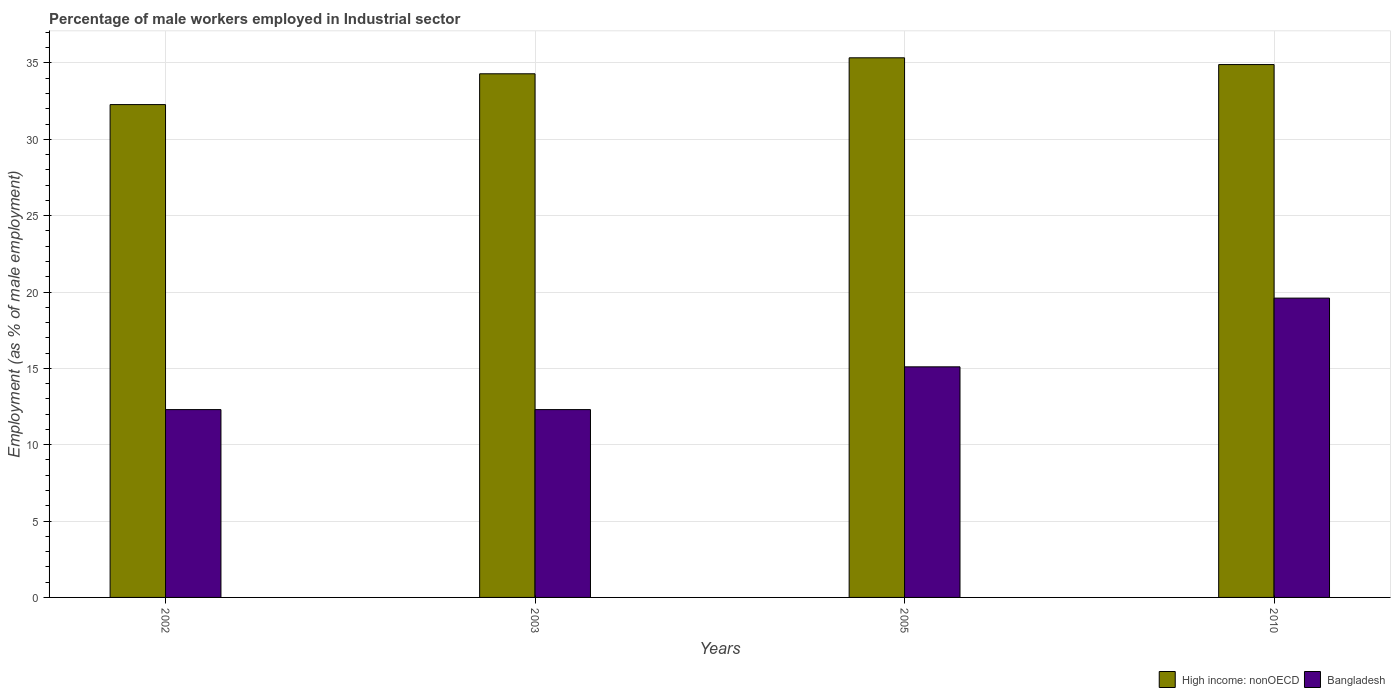How many different coloured bars are there?
Ensure brevity in your answer.  2. How many groups of bars are there?
Give a very brief answer. 4. Are the number of bars per tick equal to the number of legend labels?
Your answer should be compact. Yes. Are the number of bars on each tick of the X-axis equal?
Offer a terse response. Yes. How many bars are there on the 1st tick from the left?
Your answer should be compact. 2. What is the label of the 2nd group of bars from the left?
Provide a succinct answer. 2003. In how many cases, is the number of bars for a given year not equal to the number of legend labels?
Make the answer very short. 0. What is the percentage of male workers employed in Industrial sector in Bangladesh in 2002?
Make the answer very short. 12.3. Across all years, what is the maximum percentage of male workers employed in Industrial sector in High income: nonOECD?
Your response must be concise. 35.34. Across all years, what is the minimum percentage of male workers employed in Industrial sector in Bangladesh?
Make the answer very short. 12.3. What is the total percentage of male workers employed in Industrial sector in Bangladesh in the graph?
Provide a short and direct response. 59.3. What is the difference between the percentage of male workers employed in Industrial sector in High income: nonOECD in 2003 and that in 2010?
Ensure brevity in your answer.  -0.6. What is the difference between the percentage of male workers employed in Industrial sector in High income: nonOECD in 2010 and the percentage of male workers employed in Industrial sector in Bangladesh in 2005?
Your answer should be very brief. 19.79. What is the average percentage of male workers employed in Industrial sector in High income: nonOECD per year?
Your answer should be compact. 34.2. In the year 2010, what is the difference between the percentage of male workers employed in Industrial sector in Bangladesh and percentage of male workers employed in Industrial sector in High income: nonOECD?
Make the answer very short. -15.29. In how many years, is the percentage of male workers employed in Industrial sector in Bangladesh greater than 11 %?
Keep it short and to the point. 4. Is the percentage of male workers employed in Industrial sector in Bangladesh in 2005 less than that in 2010?
Keep it short and to the point. Yes. What is the difference between the highest and the second highest percentage of male workers employed in Industrial sector in High income: nonOECD?
Your answer should be very brief. 0.44. What is the difference between the highest and the lowest percentage of male workers employed in Industrial sector in Bangladesh?
Ensure brevity in your answer.  7.3. Is the sum of the percentage of male workers employed in Industrial sector in Bangladesh in 2003 and 2010 greater than the maximum percentage of male workers employed in Industrial sector in High income: nonOECD across all years?
Offer a terse response. No. What does the 2nd bar from the left in 2010 represents?
Ensure brevity in your answer.  Bangladesh. Does the graph contain grids?
Provide a short and direct response. Yes. Where does the legend appear in the graph?
Provide a succinct answer. Bottom right. How are the legend labels stacked?
Your answer should be very brief. Horizontal. What is the title of the graph?
Ensure brevity in your answer.  Percentage of male workers employed in Industrial sector. What is the label or title of the X-axis?
Your answer should be very brief. Years. What is the label or title of the Y-axis?
Offer a terse response. Employment (as % of male employment). What is the Employment (as % of male employment) of High income: nonOECD in 2002?
Make the answer very short. 32.27. What is the Employment (as % of male employment) of Bangladesh in 2002?
Your answer should be very brief. 12.3. What is the Employment (as % of male employment) in High income: nonOECD in 2003?
Your answer should be compact. 34.29. What is the Employment (as % of male employment) in Bangladesh in 2003?
Give a very brief answer. 12.3. What is the Employment (as % of male employment) in High income: nonOECD in 2005?
Give a very brief answer. 35.34. What is the Employment (as % of male employment) of Bangladesh in 2005?
Your response must be concise. 15.1. What is the Employment (as % of male employment) in High income: nonOECD in 2010?
Ensure brevity in your answer.  34.89. What is the Employment (as % of male employment) in Bangladesh in 2010?
Give a very brief answer. 19.6. Across all years, what is the maximum Employment (as % of male employment) of High income: nonOECD?
Keep it short and to the point. 35.34. Across all years, what is the maximum Employment (as % of male employment) in Bangladesh?
Provide a succinct answer. 19.6. Across all years, what is the minimum Employment (as % of male employment) of High income: nonOECD?
Offer a very short reply. 32.27. Across all years, what is the minimum Employment (as % of male employment) in Bangladesh?
Your response must be concise. 12.3. What is the total Employment (as % of male employment) of High income: nonOECD in the graph?
Your response must be concise. 136.79. What is the total Employment (as % of male employment) in Bangladesh in the graph?
Keep it short and to the point. 59.3. What is the difference between the Employment (as % of male employment) of High income: nonOECD in 2002 and that in 2003?
Give a very brief answer. -2.02. What is the difference between the Employment (as % of male employment) in High income: nonOECD in 2002 and that in 2005?
Make the answer very short. -3.06. What is the difference between the Employment (as % of male employment) of Bangladesh in 2002 and that in 2005?
Provide a short and direct response. -2.8. What is the difference between the Employment (as % of male employment) in High income: nonOECD in 2002 and that in 2010?
Your response must be concise. -2.62. What is the difference between the Employment (as % of male employment) of High income: nonOECD in 2003 and that in 2005?
Offer a very short reply. -1.05. What is the difference between the Employment (as % of male employment) of High income: nonOECD in 2003 and that in 2010?
Give a very brief answer. -0.6. What is the difference between the Employment (as % of male employment) of Bangladesh in 2003 and that in 2010?
Keep it short and to the point. -7.3. What is the difference between the Employment (as % of male employment) of High income: nonOECD in 2005 and that in 2010?
Your answer should be compact. 0.44. What is the difference between the Employment (as % of male employment) of Bangladesh in 2005 and that in 2010?
Keep it short and to the point. -4.5. What is the difference between the Employment (as % of male employment) in High income: nonOECD in 2002 and the Employment (as % of male employment) in Bangladesh in 2003?
Give a very brief answer. 19.97. What is the difference between the Employment (as % of male employment) in High income: nonOECD in 2002 and the Employment (as % of male employment) in Bangladesh in 2005?
Your answer should be very brief. 17.17. What is the difference between the Employment (as % of male employment) in High income: nonOECD in 2002 and the Employment (as % of male employment) in Bangladesh in 2010?
Offer a very short reply. 12.67. What is the difference between the Employment (as % of male employment) of High income: nonOECD in 2003 and the Employment (as % of male employment) of Bangladesh in 2005?
Offer a very short reply. 19.19. What is the difference between the Employment (as % of male employment) in High income: nonOECD in 2003 and the Employment (as % of male employment) in Bangladesh in 2010?
Provide a succinct answer. 14.69. What is the difference between the Employment (as % of male employment) in High income: nonOECD in 2005 and the Employment (as % of male employment) in Bangladesh in 2010?
Offer a very short reply. 15.74. What is the average Employment (as % of male employment) in High income: nonOECD per year?
Make the answer very short. 34.2. What is the average Employment (as % of male employment) in Bangladesh per year?
Make the answer very short. 14.82. In the year 2002, what is the difference between the Employment (as % of male employment) of High income: nonOECD and Employment (as % of male employment) of Bangladesh?
Give a very brief answer. 19.97. In the year 2003, what is the difference between the Employment (as % of male employment) in High income: nonOECD and Employment (as % of male employment) in Bangladesh?
Ensure brevity in your answer.  21.99. In the year 2005, what is the difference between the Employment (as % of male employment) of High income: nonOECD and Employment (as % of male employment) of Bangladesh?
Your response must be concise. 20.24. In the year 2010, what is the difference between the Employment (as % of male employment) of High income: nonOECD and Employment (as % of male employment) of Bangladesh?
Provide a succinct answer. 15.29. What is the ratio of the Employment (as % of male employment) of High income: nonOECD in 2002 to that in 2005?
Ensure brevity in your answer.  0.91. What is the ratio of the Employment (as % of male employment) of Bangladesh in 2002 to that in 2005?
Offer a terse response. 0.81. What is the ratio of the Employment (as % of male employment) in High income: nonOECD in 2002 to that in 2010?
Offer a terse response. 0.92. What is the ratio of the Employment (as % of male employment) in Bangladesh in 2002 to that in 2010?
Provide a short and direct response. 0.63. What is the ratio of the Employment (as % of male employment) of High income: nonOECD in 2003 to that in 2005?
Ensure brevity in your answer.  0.97. What is the ratio of the Employment (as % of male employment) in Bangladesh in 2003 to that in 2005?
Give a very brief answer. 0.81. What is the ratio of the Employment (as % of male employment) of High income: nonOECD in 2003 to that in 2010?
Ensure brevity in your answer.  0.98. What is the ratio of the Employment (as % of male employment) of Bangladesh in 2003 to that in 2010?
Provide a succinct answer. 0.63. What is the ratio of the Employment (as % of male employment) of High income: nonOECD in 2005 to that in 2010?
Your answer should be compact. 1.01. What is the ratio of the Employment (as % of male employment) of Bangladesh in 2005 to that in 2010?
Give a very brief answer. 0.77. What is the difference between the highest and the second highest Employment (as % of male employment) of High income: nonOECD?
Give a very brief answer. 0.44. What is the difference between the highest and the lowest Employment (as % of male employment) in High income: nonOECD?
Make the answer very short. 3.06. What is the difference between the highest and the lowest Employment (as % of male employment) of Bangladesh?
Provide a succinct answer. 7.3. 